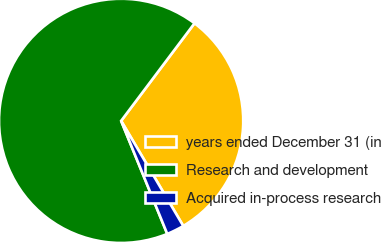Convert chart to OTSL. <chart><loc_0><loc_0><loc_500><loc_500><pie_chart><fcel>years ended December 31 (in<fcel>Research and development<fcel>Acquired in-process research<nl><fcel>31.24%<fcel>66.43%<fcel>2.33%<nl></chart> 